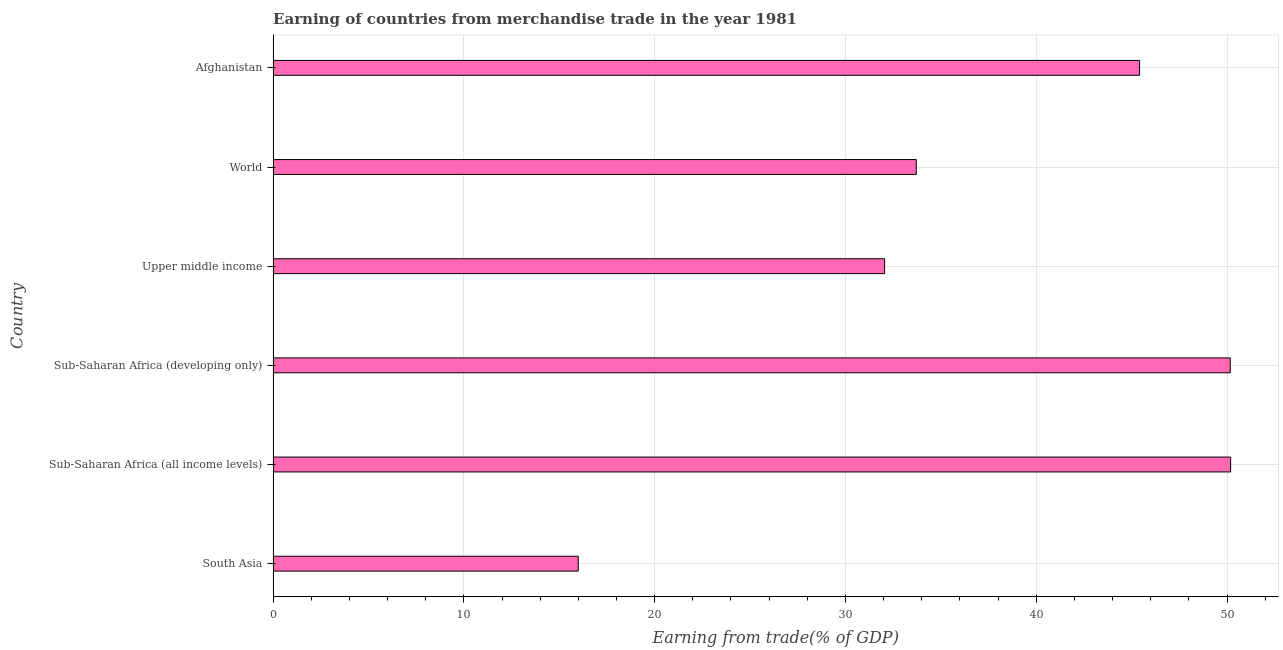Does the graph contain any zero values?
Your answer should be compact. No. What is the title of the graph?
Offer a very short reply. Earning of countries from merchandise trade in the year 1981. What is the label or title of the X-axis?
Make the answer very short. Earning from trade(% of GDP). What is the earning from merchandise trade in Upper middle income?
Offer a terse response. 32.05. Across all countries, what is the maximum earning from merchandise trade?
Offer a terse response. 50.19. Across all countries, what is the minimum earning from merchandise trade?
Provide a short and direct response. 15.99. In which country was the earning from merchandise trade maximum?
Offer a very short reply. Sub-Saharan Africa (all income levels). What is the sum of the earning from merchandise trade?
Your answer should be compact. 227.54. What is the difference between the earning from merchandise trade in Afghanistan and Sub-Saharan Africa (all income levels)?
Keep it short and to the point. -4.77. What is the average earning from merchandise trade per country?
Provide a short and direct response. 37.92. What is the median earning from merchandise trade?
Provide a succinct answer. 39.57. What is the ratio of the earning from merchandise trade in Sub-Saharan Africa (developing only) to that in Upper middle income?
Your response must be concise. 1.56. Is the earning from merchandise trade in South Asia less than that in Sub-Saharan Africa (all income levels)?
Your answer should be very brief. Yes. What is the difference between the highest and the lowest earning from merchandise trade?
Provide a short and direct response. 34.2. Are all the bars in the graph horizontal?
Provide a short and direct response. Yes. How many countries are there in the graph?
Offer a terse response. 6. What is the Earning from trade(% of GDP) of South Asia?
Provide a succinct answer. 15.99. What is the Earning from trade(% of GDP) in Sub-Saharan Africa (all income levels)?
Make the answer very short. 50.19. What is the Earning from trade(% of GDP) in Sub-Saharan Africa (developing only)?
Your response must be concise. 50.17. What is the Earning from trade(% of GDP) in Upper middle income?
Provide a short and direct response. 32.05. What is the Earning from trade(% of GDP) in World?
Your response must be concise. 33.71. What is the Earning from trade(% of GDP) of Afghanistan?
Make the answer very short. 45.42. What is the difference between the Earning from trade(% of GDP) in South Asia and Sub-Saharan Africa (all income levels)?
Provide a short and direct response. -34.2. What is the difference between the Earning from trade(% of GDP) in South Asia and Sub-Saharan Africa (developing only)?
Provide a short and direct response. -34.18. What is the difference between the Earning from trade(% of GDP) in South Asia and Upper middle income?
Your answer should be compact. -16.06. What is the difference between the Earning from trade(% of GDP) in South Asia and World?
Offer a very short reply. -17.72. What is the difference between the Earning from trade(% of GDP) in South Asia and Afghanistan?
Your response must be concise. -29.43. What is the difference between the Earning from trade(% of GDP) in Sub-Saharan Africa (all income levels) and Sub-Saharan Africa (developing only)?
Offer a very short reply. 0.02. What is the difference between the Earning from trade(% of GDP) in Sub-Saharan Africa (all income levels) and Upper middle income?
Your response must be concise. 18.14. What is the difference between the Earning from trade(% of GDP) in Sub-Saharan Africa (all income levels) and World?
Make the answer very short. 16.48. What is the difference between the Earning from trade(% of GDP) in Sub-Saharan Africa (all income levels) and Afghanistan?
Ensure brevity in your answer.  4.77. What is the difference between the Earning from trade(% of GDP) in Sub-Saharan Africa (developing only) and Upper middle income?
Provide a succinct answer. 18.12. What is the difference between the Earning from trade(% of GDP) in Sub-Saharan Africa (developing only) and World?
Make the answer very short. 16.46. What is the difference between the Earning from trade(% of GDP) in Sub-Saharan Africa (developing only) and Afghanistan?
Your answer should be very brief. 4.75. What is the difference between the Earning from trade(% of GDP) in Upper middle income and World?
Provide a short and direct response. -1.66. What is the difference between the Earning from trade(% of GDP) in Upper middle income and Afghanistan?
Give a very brief answer. -13.36. What is the difference between the Earning from trade(% of GDP) in World and Afghanistan?
Provide a succinct answer. -11.71. What is the ratio of the Earning from trade(% of GDP) in South Asia to that in Sub-Saharan Africa (all income levels)?
Offer a terse response. 0.32. What is the ratio of the Earning from trade(% of GDP) in South Asia to that in Sub-Saharan Africa (developing only)?
Your answer should be very brief. 0.32. What is the ratio of the Earning from trade(% of GDP) in South Asia to that in Upper middle income?
Offer a terse response. 0.5. What is the ratio of the Earning from trade(% of GDP) in South Asia to that in World?
Provide a succinct answer. 0.47. What is the ratio of the Earning from trade(% of GDP) in South Asia to that in Afghanistan?
Provide a succinct answer. 0.35. What is the ratio of the Earning from trade(% of GDP) in Sub-Saharan Africa (all income levels) to that in Sub-Saharan Africa (developing only)?
Give a very brief answer. 1. What is the ratio of the Earning from trade(% of GDP) in Sub-Saharan Africa (all income levels) to that in Upper middle income?
Your answer should be very brief. 1.57. What is the ratio of the Earning from trade(% of GDP) in Sub-Saharan Africa (all income levels) to that in World?
Give a very brief answer. 1.49. What is the ratio of the Earning from trade(% of GDP) in Sub-Saharan Africa (all income levels) to that in Afghanistan?
Your answer should be very brief. 1.1. What is the ratio of the Earning from trade(% of GDP) in Sub-Saharan Africa (developing only) to that in Upper middle income?
Offer a terse response. 1.56. What is the ratio of the Earning from trade(% of GDP) in Sub-Saharan Africa (developing only) to that in World?
Your answer should be compact. 1.49. What is the ratio of the Earning from trade(% of GDP) in Sub-Saharan Africa (developing only) to that in Afghanistan?
Provide a short and direct response. 1.1. What is the ratio of the Earning from trade(% of GDP) in Upper middle income to that in World?
Provide a short and direct response. 0.95. What is the ratio of the Earning from trade(% of GDP) in Upper middle income to that in Afghanistan?
Provide a short and direct response. 0.71. What is the ratio of the Earning from trade(% of GDP) in World to that in Afghanistan?
Make the answer very short. 0.74. 